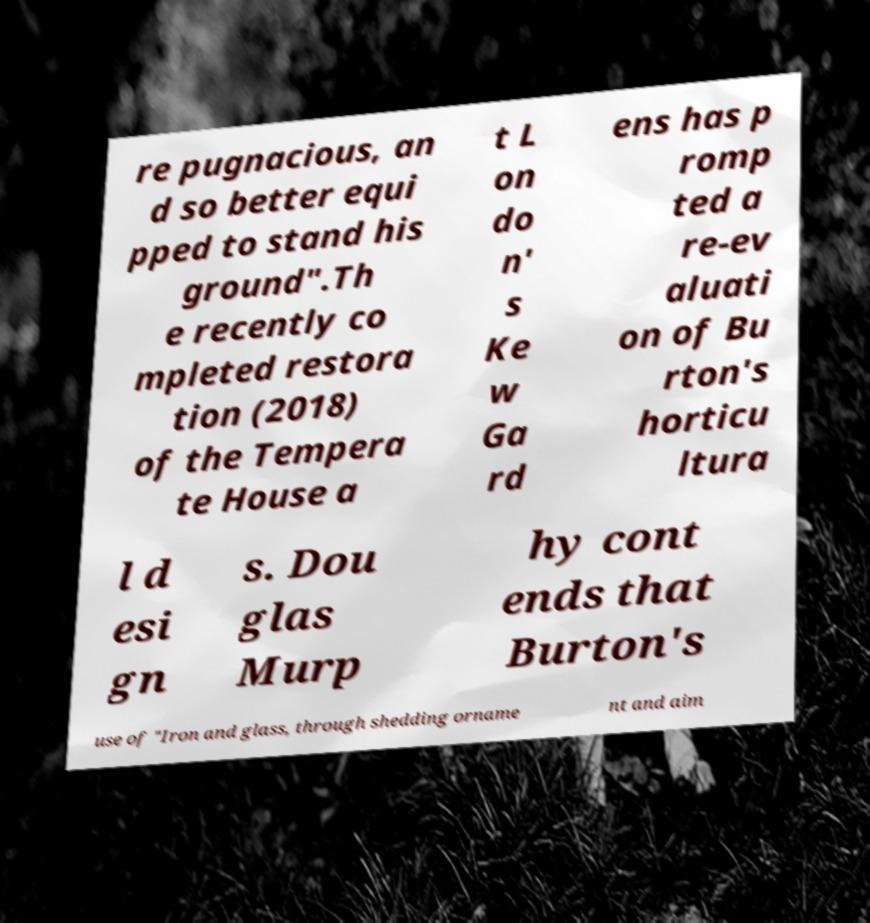There's text embedded in this image that I need extracted. Can you transcribe it verbatim? re pugnacious, an d so better equi pped to stand his ground".Th e recently co mpleted restora tion (2018) of the Tempera te House a t L on do n' s Ke w Ga rd ens has p romp ted a re-ev aluati on of Bu rton's horticu ltura l d esi gn s. Dou glas Murp hy cont ends that Burton's use of "Iron and glass, through shedding orname nt and aim 